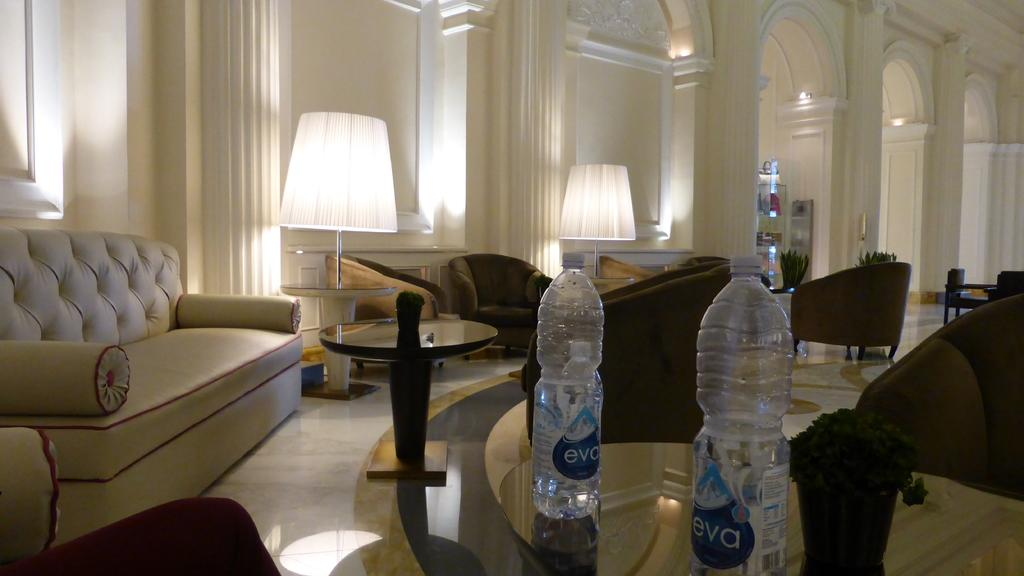Where was the image taken? The image was taken inside a hall. What type of seating is available in the hall? There are sofas and chairs in the hall. What type of lighting is present in the hall? There are lamps in the hall. What type of furniture is present in the hall? There is a table in the hall. What items can be seen on the table? There are two bottles on the table. What can be seen in the background of the image? There is a wall in the background of the image. Can you see any lizards joining the battle in the image? There are no lizards or battles present in the image. 